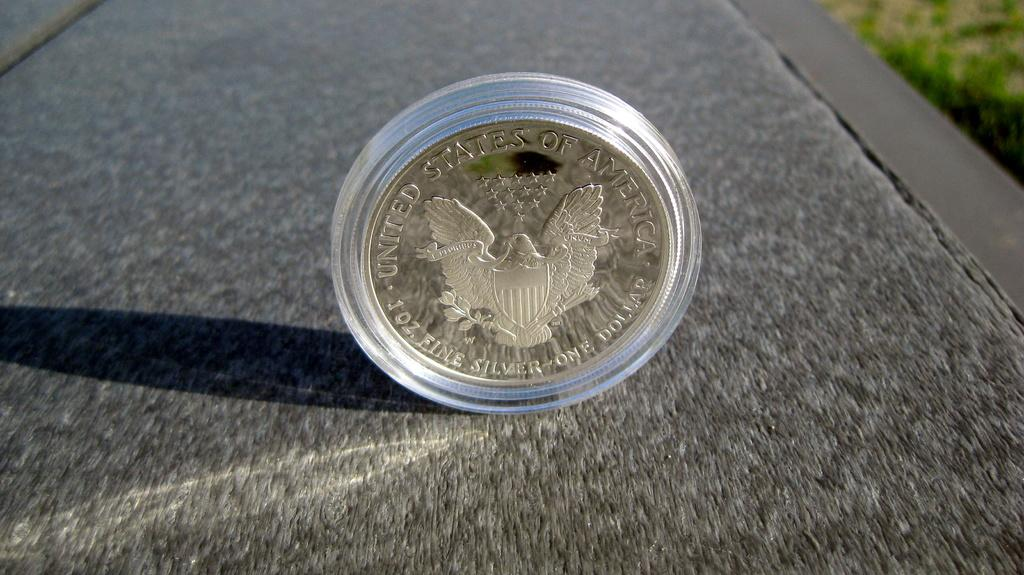<image>
Create a compact narrative representing the image presented. A coin with United States Silver one dollar on it 